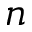Convert formula to latex. <formula><loc_0><loc_0><loc_500><loc_500>n</formula> 